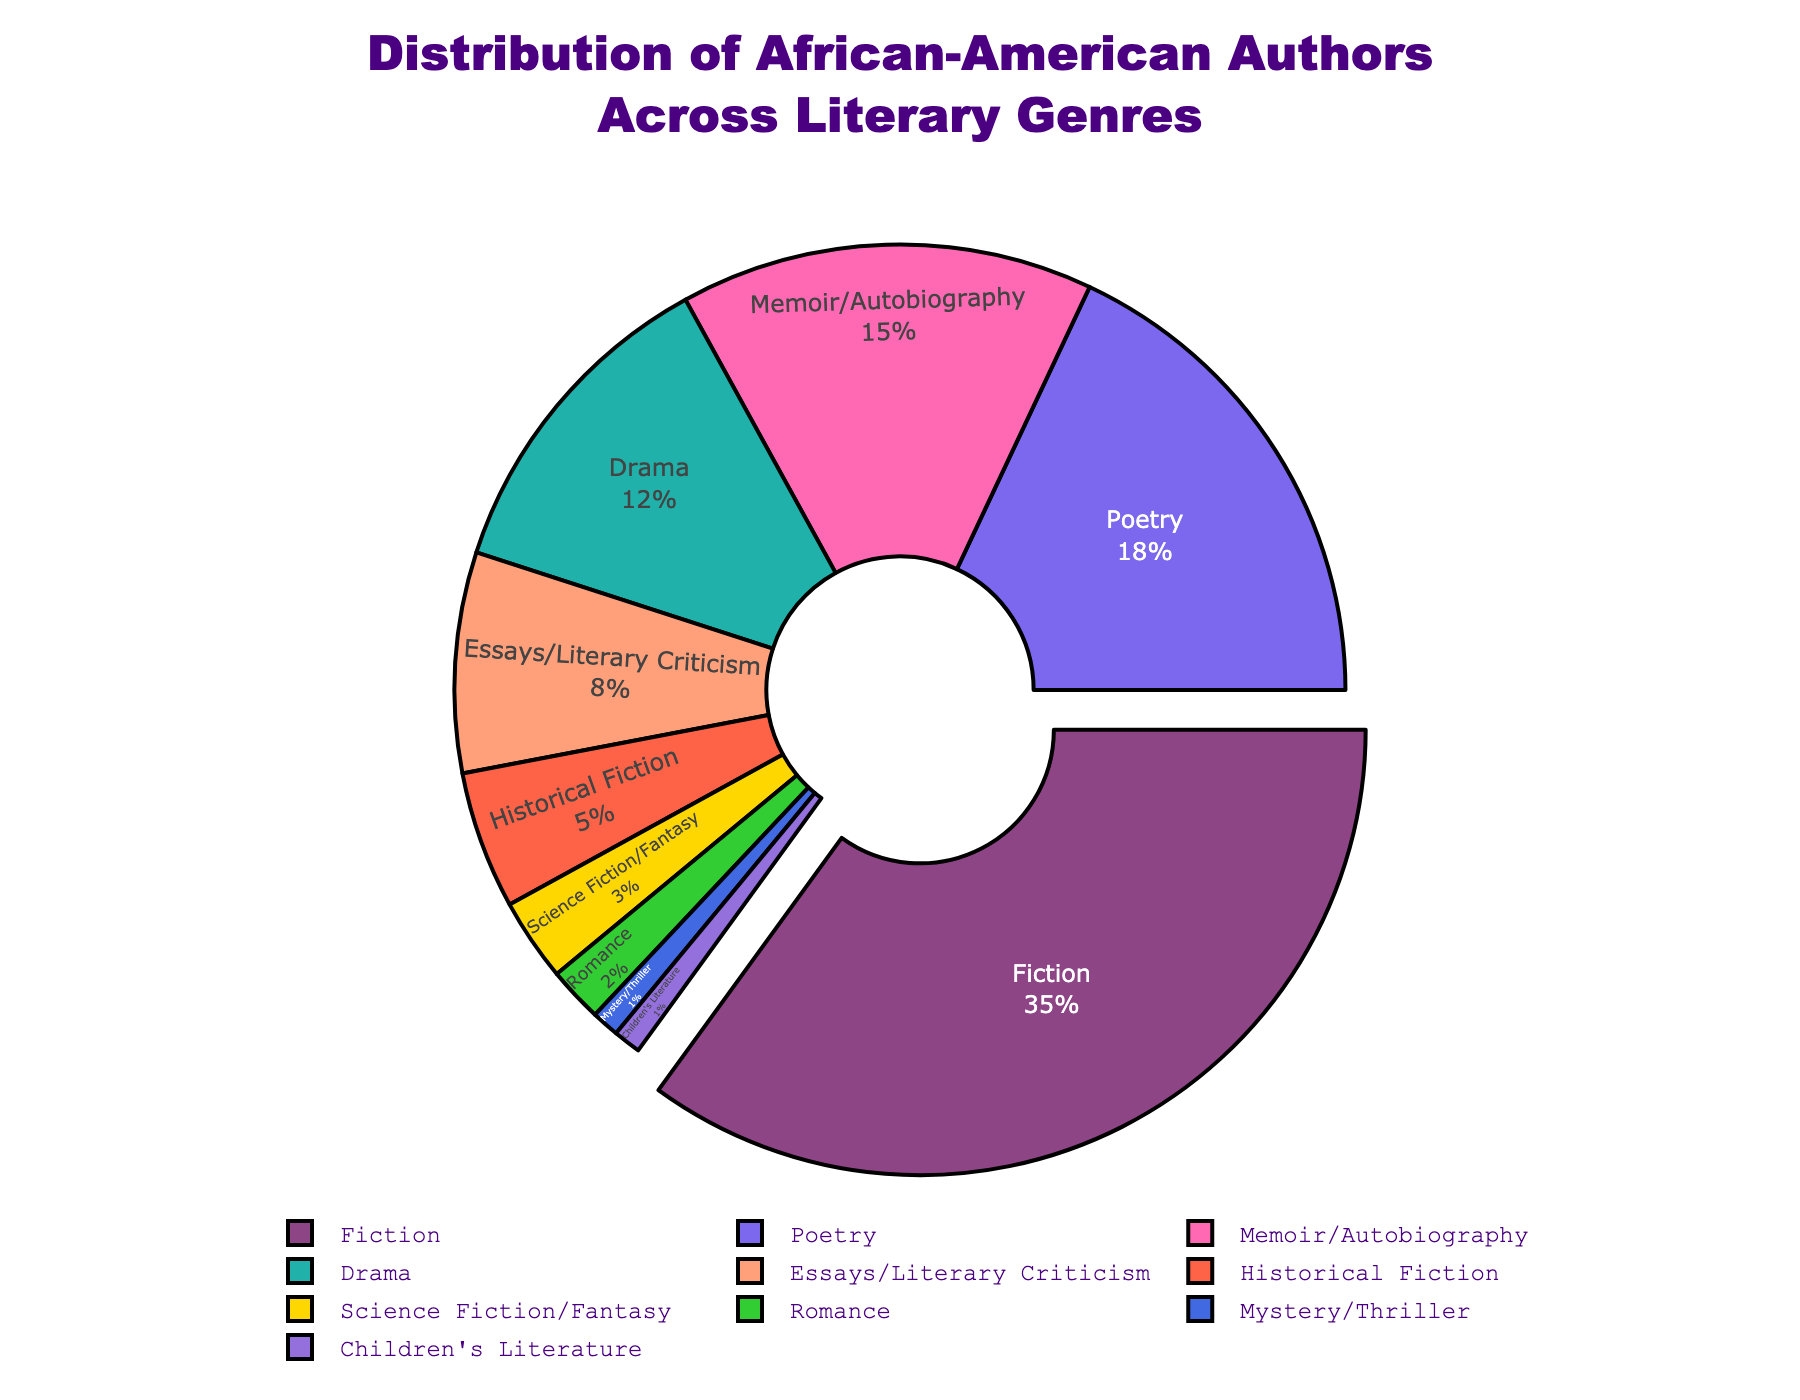What genre has the highest percentage of African-American authors? The slice that is pulled out from the pie chart represents the genre with the highest percentage. By looking at the plot, we see that Fiction has the highest percentage.
Answer: Fiction What is the combined percentage of authors in Poetry and Drama? Add the percentage values of Poetry (18%) and Drama (12%) from the chart. 18% + 12% = 30%.
Answer: 30% Which genre has the smallest representation among African-American authors? The smallest slice in the pie chart corresponds to the genre with only 1% representation. Both Mystery/Thriller and Children's Literature have 1%, but the order listed in the legend also matters.
Answer: Mystery/Thriller (or Children’s Literature) How much higher is the percentage of Fiction compared to Science Fiction/Fantasy? Subtract the percentage of Science Fiction/Fantasy (3%) from the percentage of Fiction (35%). 35% - 3% = 32%.
Answer: 32% What is the average percentage of Memoir/Autobiography, Historical Fiction, and Romance? Calculate the average by adding Memoir/Autobiography (15%), Historical Fiction (5%), and Romance (2%), then divide by 3. (15% + 5% + 2%) / 3 = 22% / 3 ≈ 7.33%.
Answer: 7.33% Which genre occupies a larger slice, Historical Fiction or Essays/Literary Criticism? Compare the percentage values from the pie chart; Historical Fiction has 5%, while Essays/Literary Criticism has 8%. Essays/Literary Criticism has a larger slice.
Answer: Essays/Literary Criticism What color represents Poetry in the pie chart? By examining the pie chart, the color assigned to Poetry can be identified by visual inspection. Poetry is colored in a light purple shade.
Answer: Purple How many genres have a percentage lower than 10%? Count the genres in the chart with values lower than 10%: Essays/Literary Criticism (8%), Historical Fiction (5%), Science Fiction/Fantasy (3%), Romance (2%), Mystery/Thriller (1%), and Children's Literature (1%). This gives a total of 6 genres.
Answer: 6 genres What is the total percentage covered by Fiction, Memoir/Autobiography, and Children’s Literature? Add the percentage values of Fiction (35%), Memoir/Autobiography (15%), and Children’s Literature (1%). 35% + 15% + 1% = 51%.
Answer: 51% What genre is represented by a green slice in the chart? Visual inspection of the pie chart shows that the green slice corresponds to Drama.
Answer: Drama 